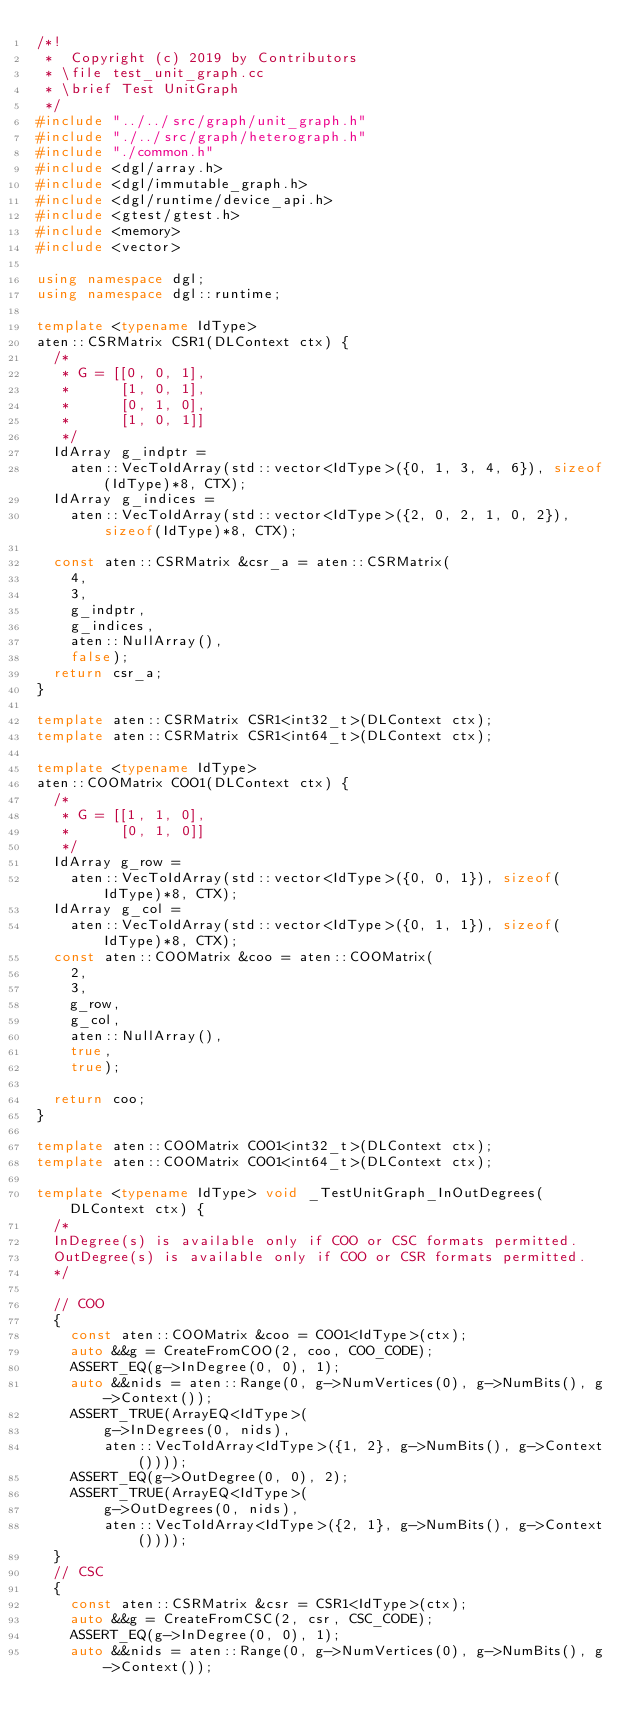<code> <loc_0><loc_0><loc_500><loc_500><_C++_>/*!
 *  Copyright (c) 2019 by Contributors
 * \file test_unit_graph.cc
 * \brief Test UnitGraph
 */
#include "../../src/graph/unit_graph.h"
#include "./../src/graph/heterograph.h"
#include "./common.h"
#include <dgl/array.h>
#include <dgl/immutable_graph.h>
#include <dgl/runtime/device_api.h>
#include <gtest/gtest.h>
#include <memory>
#include <vector>

using namespace dgl;
using namespace dgl::runtime;

template <typename IdType>
aten::CSRMatrix CSR1(DLContext ctx) {
  /*
   * G = [[0, 0, 1],
   *      [1, 0, 1],
   *      [0, 1, 0],
   *      [1, 0, 1]]
   */
  IdArray g_indptr =
    aten::VecToIdArray(std::vector<IdType>({0, 1, 3, 4, 6}), sizeof(IdType)*8, CTX);
  IdArray g_indices =
    aten::VecToIdArray(std::vector<IdType>({2, 0, 2, 1, 0, 2}), sizeof(IdType)*8, CTX);

  const aten::CSRMatrix &csr_a = aten::CSRMatrix(
    4,
    3,
    g_indptr,
    g_indices,
    aten::NullArray(),
    false);
  return csr_a;
}

template aten::CSRMatrix CSR1<int32_t>(DLContext ctx);
template aten::CSRMatrix CSR1<int64_t>(DLContext ctx);

template <typename IdType>
aten::COOMatrix COO1(DLContext ctx) {
  /*
   * G = [[1, 1, 0],
   *      [0, 1, 0]]
   */
  IdArray g_row =
    aten::VecToIdArray(std::vector<IdType>({0, 0, 1}), sizeof(IdType)*8, CTX);
  IdArray g_col =
    aten::VecToIdArray(std::vector<IdType>({0, 1, 1}), sizeof(IdType)*8, CTX);
  const aten::COOMatrix &coo = aten::COOMatrix(
    2,
    3,
    g_row,
    g_col,
    aten::NullArray(),
    true,
    true);

  return coo;
}

template aten::COOMatrix COO1<int32_t>(DLContext ctx);
template aten::COOMatrix COO1<int64_t>(DLContext ctx);

template <typename IdType> void _TestUnitGraph_InOutDegrees(DLContext ctx) {
  /*
  InDegree(s) is available only if COO or CSC formats permitted.
  OutDegree(s) is available only if COO or CSR formats permitted.
  */

  // COO
  {
    const aten::COOMatrix &coo = COO1<IdType>(ctx);
    auto &&g = CreateFromCOO(2, coo, COO_CODE);
    ASSERT_EQ(g->InDegree(0, 0), 1);
    auto &&nids = aten::Range(0, g->NumVertices(0), g->NumBits(), g->Context());
    ASSERT_TRUE(ArrayEQ<IdType>(
        g->InDegrees(0, nids),
        aten::VecToIdArray<IdType>({1, 2}, g->NumBits(), g->Context())));
    ASSERT_EQ(g->OutDegree(0, 0), 2);
    ASSERT_TRUE(ArrayEQ<IdType>(
        g->OutDegrees(0, nids),
        aten::VecToIdArray<IdType>({2, 1}, g->NumBits(), g->Context())));
  }
  // CSC
  {
    const aten::CSRMatrix &csr = CSR1<IdType>(ctx);
    auto &&g = CreateFromCSC(2, csr, CSC_CODE);
    ASSERT_EQ(g->InDegree(0, 0), 1);
    auto &&nids = aten::Range(0, g->NumVertices(0), g->NumBits(), g->Context());</code> 